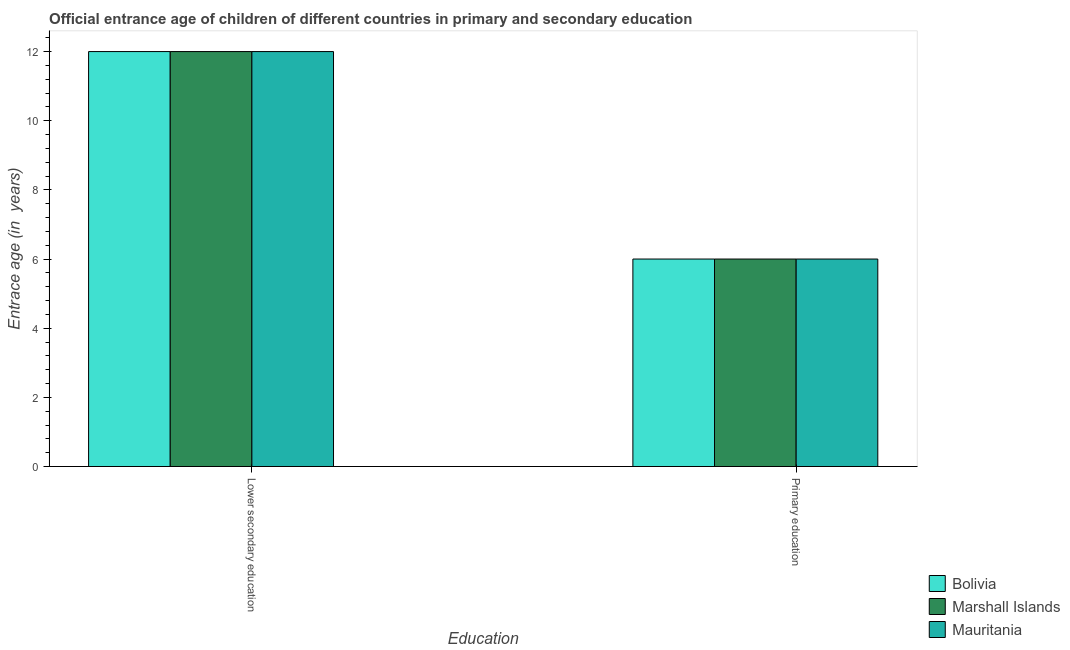How many different coloured bars are there?
Make the answer very short. 3. How many groups of bars are there?
Make the answer very short. 2. Are the number of bars per tick equal to the number of legend labels?
Provide a short and direct response. Yes. Are the number of bars on each tick of the X-axis equal?
Your response must be concise. Yes. How many bars are there on the 1st tick from the right?
Make the answer very short. 3. Across all countries, what is the minimum entrance age of chiildren in primary education?
Keep it short and to the point. 6. In which country was the entrance age of chiildren in primary education maximum?
Offer a very short reply. Bolivia. In which country was the entrance age of children in lower secondary education minimum?
Offer a terse response. Bolivia. What is the total entrance age of children in lower secondary education in the graph?
Make the answer very short. 36. What is the difference between the entrance age of chiildren in primary education in Bolivia and the entrance age of children in lower secondary education in Mauritania?
Your answer should be very brief. -6. What is the difference between the entrance age of chiildren in primary education and entrance age of children in lower secondary education in Marshall Islands?
Your answer should be compact. -6. In how many countries, is the entrance age of chiildren in primary education greater than 4.8 years?
Ensure brevity in your answer.  3. Is the entrance age of children in lower secondary education in Marshall Islands less than that in Bolivia?
Provide a succinct answer. No. In how many countries, is the entrance age of children in lower secondary education greater than the average entrance age of children in lower secondary education taken over all countries?
Provide a succinct answer. 0. What does the 3rd bar from the left in Primary education represents?
Give a very brief answer. Mauritania. What does the 2nd bar from the right in Lower secondary education represents?
Your answer should be very brief. Marshall Islands. How many bars are there?
Keep it short and to the point. 6. Are the values on the major ticks of Y-axis written in scientific E-notation?
Your response must be concise. No. Does the graph contain any zero values?
Provide a short and direct response. No. What is the title of the graph?
Your answer should be very brief. Official entrance age of children of different countries in primary and secondary education. What is the label or title of the X-axis?
Provide a short and direct response. Education. What is the label or title of the Y-axis?
Your answer should be compact. Entrace age (in  years). What is the Entrace age (in  years) in Bolivia in Lower secondary education?
Make the answer very short. 12. What is the Entrace age (in  years) of Marshall Islands in Lower secondary education?
Your answer should be very brief. 12. What is the Entrace age (in  years) of Bolivia in Primary education?
Your answer should be compact. 6. What is the Entrace age (in  years) in Mauritania in Primary education?
Your answer should be very brief. 6. Across all Education, what is the maximum Entrace age (in  years) in Marshall Islands?
Provide a short and direct response. 12. Across all Education, what is the minimum Entrace age (in  years) of Marshall Islands?
Provide a succinct answer. 6. Across all Education, what is the minimum Entrace age (in  years) in Mauritania?
Offer a terse response. 6. What is the total Entrace age (in  years) of Mauritania in the graph?
Make the answer very short. 18. What is the difference between the Entrace age (in  years) in Bolivia in Lower secondary education and that in Primary education?
Provide a short and direct response. 6. What is the difference between the Entrace age (in  years) of Bolivia in Lower secondary education and the Entrace age (in  years) of Marshall Islands in Primary education?
Your answer should be very brief. 6. What is the average Entrace age (in  years) of Bolivia per Education?
Keep it short and to the point. 9. What is the difference between the Entrace age (in  years) of Bolivia and Entrace age (in  years) of Marshall Islands in Lower secondary education?
Make the answer very short. 0. What is the difference between the Entrace age (in  years) in Bolivia and Entrace age (in  years) in Mauritania in Lower secondary education?
Your answer should be very brief. 0. What is the difference between the Entrace age (in  years) in Marshall Islands and Entrace age (in  years) in Mauritania in Lower secondary education?
Make the answer very short. 0. What is the difference between the Entrace age (in  years) of Bolivia and Entrace age (in  years) of Marshall Islands in Primary education?
Offer a very short reply. 0. What is the difference between the Entrace age (in  years) of Marshall Islands and Entrace age (in  years) of Mauritania in Primary education?
Offer a terse response. 0. What is the ratio of the Entrace age (in  years) in Bolivia in Lower secondary education to that in Primary education?
Your response must be concise. 2. What is the ratio of the Entrace age (in  years) of Mauritania in Lower secondary education to that in Primary education?
Offer a very short reply. 2. What is the difference between the highest and the second highest Entrace age (in  years) of Marshall Islands?
Make the answer very short. 6. 